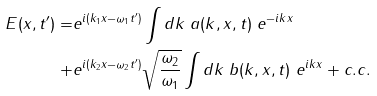Convert formula to latex. <formula><loc_0><loc_0><loc_500><loc_500>E ( x , t ^ { \prime } ) = & e ^ { i ( k _ { 1 } x - \omega _ { 1 } t ^ { \prime } ) } \int d k \ a ( k , x , t ) \ e ^ { - i k x } \\ + & e ^ { i ( k _ { 2 } x - \omega _ { 2 } t ^ { \prime } ) } \sqrt { \frac { \omega _ { 2 } } { \omega _ { 1 } } } \int d k \ b ( k , x , t ) \ e ^ { i k x } + c . c .</formula> 